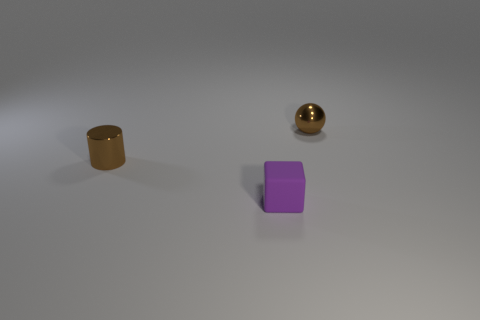Add 3 green objects. How many objects exist? 6 Subtract all blocks. How many objects are left? 2 Add 3 small cyan rubber cylinders. How many small cyan rubber cylinders exist? 3 Subtract 1 purple blocks. How many objects are left? 2 Subtract all tiny purple metallic cylinders. Subtract all brown balls. How many objects are left? 2 Add 1 tiny purple blocks. How many tiny purple blocks are left? 2 